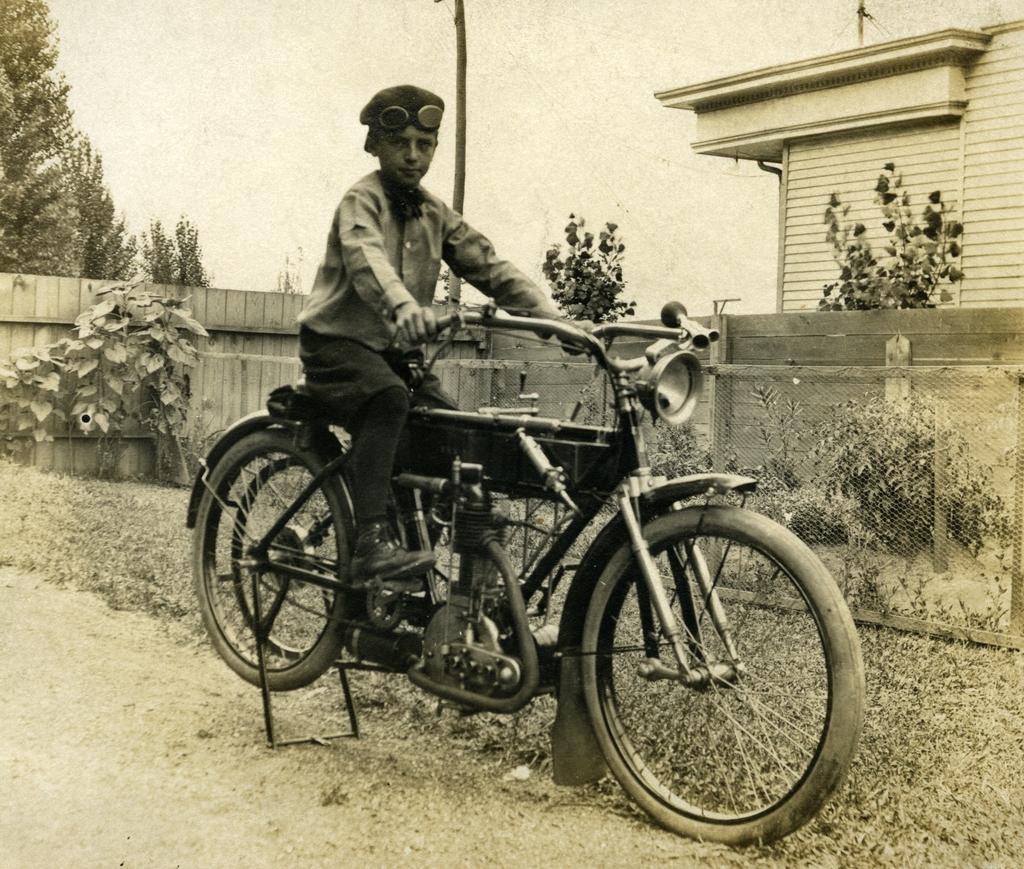Describe this image in one or two sentences. In this picture, in the middle, we can see a man riding a bicycle and the bicycle is on the road. On the right side, we can see some buildings, trees, net fence. On the left side, we can also see some plants, wood fence, trees. On top there is a sky, at the bottom there is a grass and a land. 